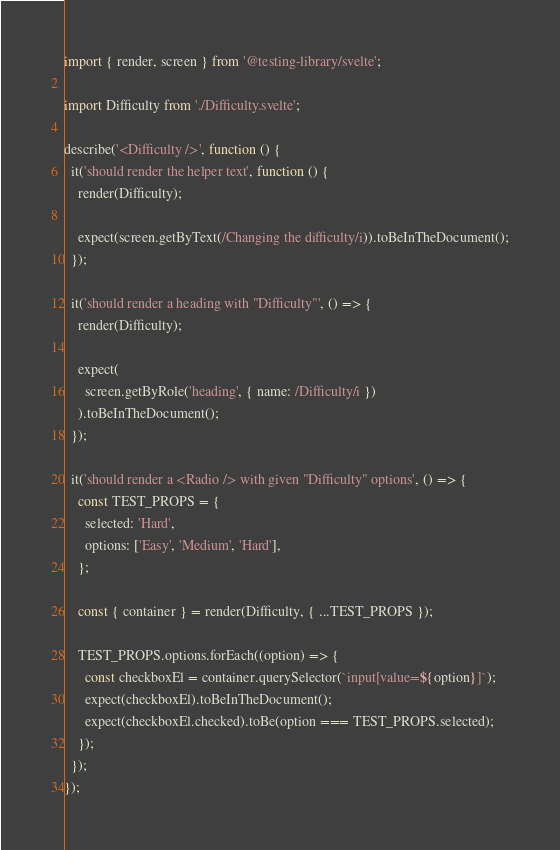<code> <loc_0><loc_0><loc_500><loc_500><_JavaScript_>import { render, screen } from '@testing-library/svelte';

import Difficulty from './Difficulty.svelte';

describe('<Difficulty />', function () {
  it('should render the helper text', function () {
    render(Difficulty);

    expect(screen.getByText(/Changing the difficulty/i)).toBeInTheDocument();
  });

  it('should render a heading with "Difficulty"', () => {
    render(Difficulty);

    expect(
      screen.getByRole('heading', { name: /Difficulty/i })
    ).toBeInTheDocument();
  });

  it('should render a <Radio /> with given "Difficulty" options', () => {
    const TEST_PROPS = {
      selected: 'Hard',
      options: ['Easy', 'Medium', 'Hard'],
    };

    const { container } = render(Difficulty, { ...TEST_PROPS });

    TEST_PROPS.options.forEach((option) => {
      const checkboxEl = container.querySelector(`input[value=${option}]`);
      expect(checkboxEl).toBeInTheDocument();
      expect(checkboxEl.checked).toBe(option === TEST_PROPS.selected);
    });
  });
});
</code> 